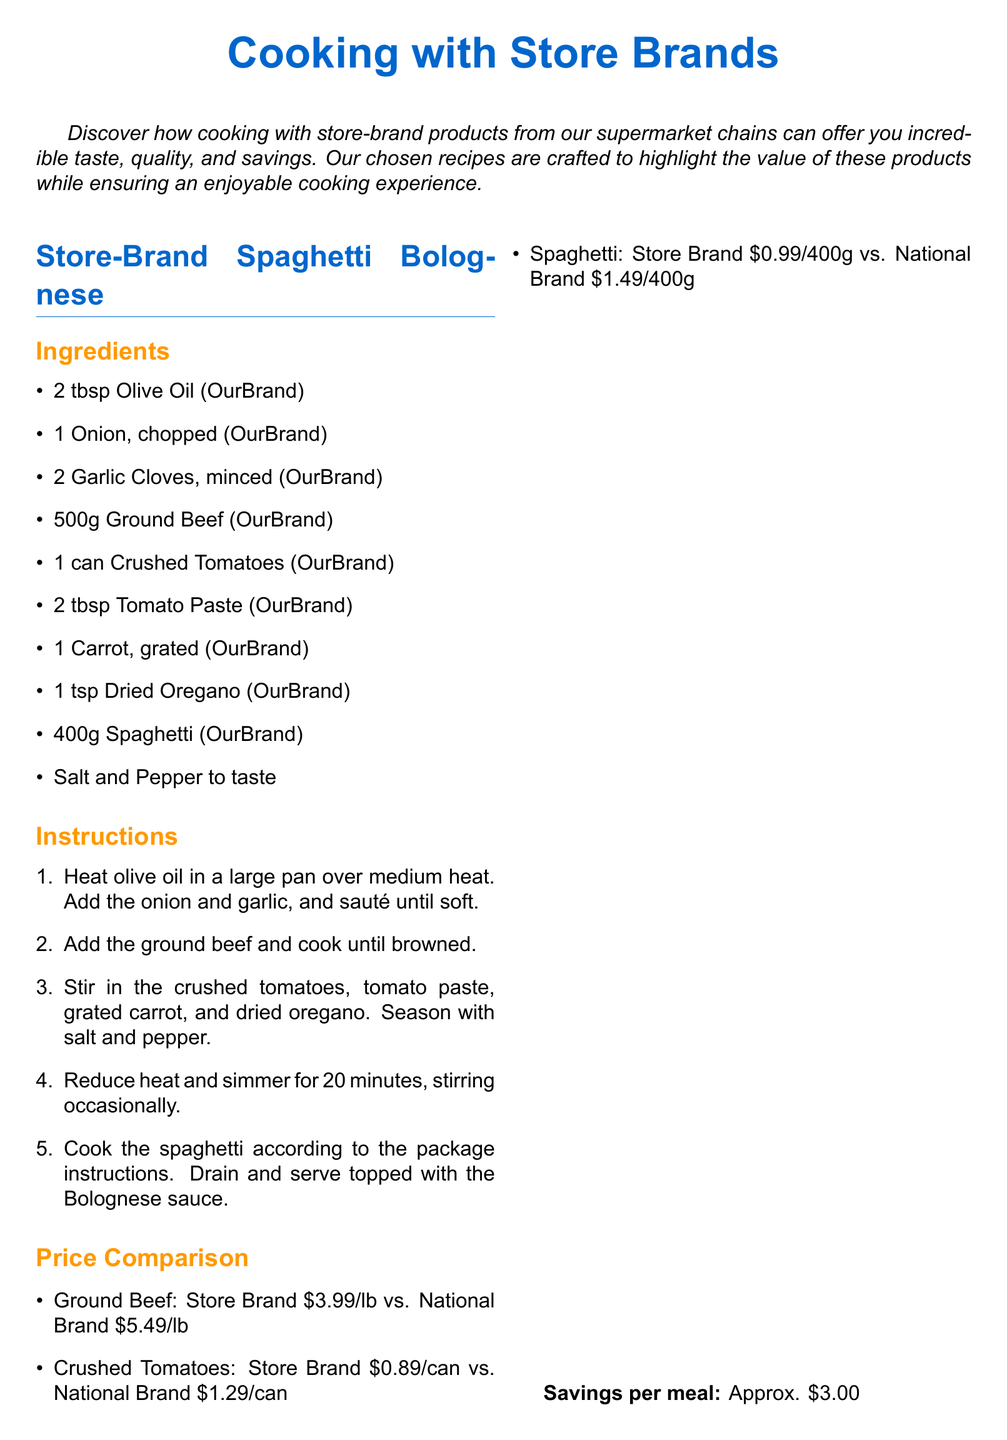what are the ingredients for Store-Brand Spaghetti Bolognese? The document lists the ingredients for Store-Brand Spaghetti Bolognese, including olive oil, onion, garlic, ground beef, crushed tomatoes, tomato paste, carrot, dried oregano, spaghetti, salt, and pepper.
Answer: Olive Oil, Onion, Garlic, Ground Beef, Crushed Tomatoes, Tomato Paste, Carrot, Dried Oregano, Spaghetti, Salt, Pepper how much does a can of crushed tomatoes cost for store brand? The price comparison section lists the cost of a can of crushed tomatoes for the store brand.
Answer: 0.89 what is the total cooking time for the Spaghetti Bolognese? The instructions indicate that the spaghetti Bolognese should be simmered for 20 minutes, following the initial cooking of other ingredients.
Answer: 20 minutes how much does the store brand soy sauce cost? The document provides a price comparison showing the cost of store brand soy sauce.
Answer: 1.29 what is the key savings per meal for OurBrand Chicken Stir-Fry? The document specifies the approximate savings per meal for OurBrand Chicken Stir-Fry.
Answer: 4.00 which ingredient has the highest cost difference between store brand and national brand in Spaghetti Bolognese? The price comparison shows the largest difference is for ground beef in Spaghetti Bolognese.
Answer: Ground Beef how many ingredients are listed for OurBrand Chicken Stir-Fry? The document counts a total of 9 ingredients for OurBrand Chicken Stir-Fry.
Answer: 9 what type of document is this? The document is structured as a recipe card showcasing recipes using store-brand products.
Answer: Recipe card 